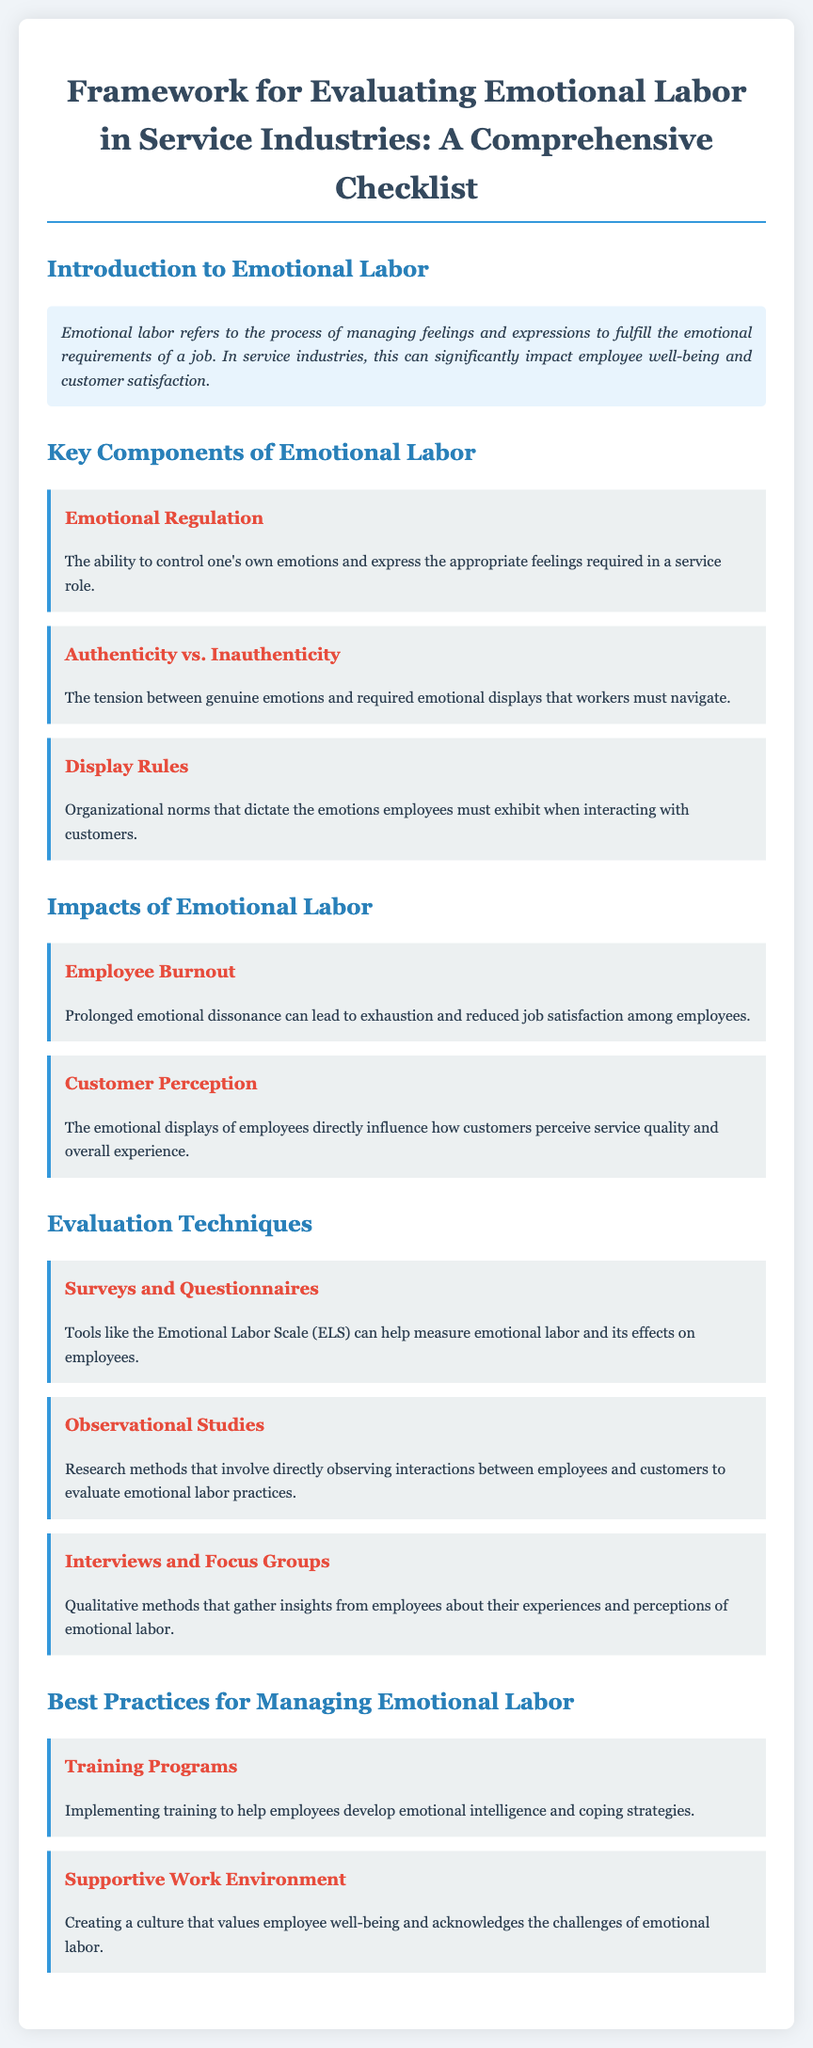What is emotional labor? Emotional labor is described in the introduction as the process of managing feelings and expressions to fulfill the emotional requirements of a job.
Answer: Managing feelings and expressions What does emotional regulation refer to? Emotional regulation is defined in the checklist as the ability to control one's own emotions and express the appropriate feelings required in a service role.
Answer: Control of own emotions What are display rules? Display rules are mentioned as organizational norms that dictate the emotions employees must exhibit when interacting with customers.
Answer: Organizational norms What can prolonged emotional dissonance lead to? The impacts section states that prolonged emotional dissonance can lead to exhaustion and reduced job satisfaction among employees.
Answer: Employee burnout Which evaluation technique involves direct observation? Observational studies are identified in the document as research methods that involve directly observing interactions between employees and customers.
Answer: Observational studies What is one of the best practices for managing emotional labor? The checklist lists training programs as one of the best practices for managing emotional labor by helping employees develop emotional intelligence.
Answer: Training programs What is the purpose of surveys and questionnaires according to the document? Surveys and questionnaires are mentioned as tools that can help measure emotional labor and its effects on employees.
Answer: Measure emotional labor What is acknowledged as important in a supportive work environment? The document indicates that a supportive work environment should create a culture that values employee well-being and acknowledges the challenges of emotional labor.
Answer: Employee well-being 